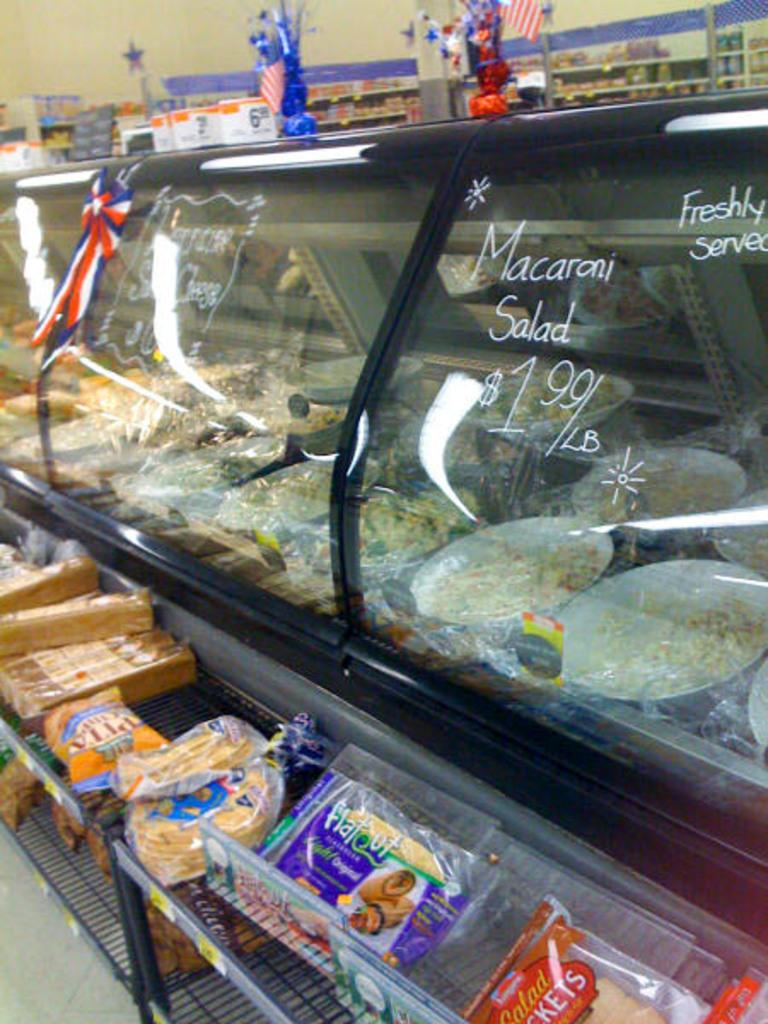Provide a one-sentence caption for the provided image. A glass case at a grocery store with macaroni salad for sale. 